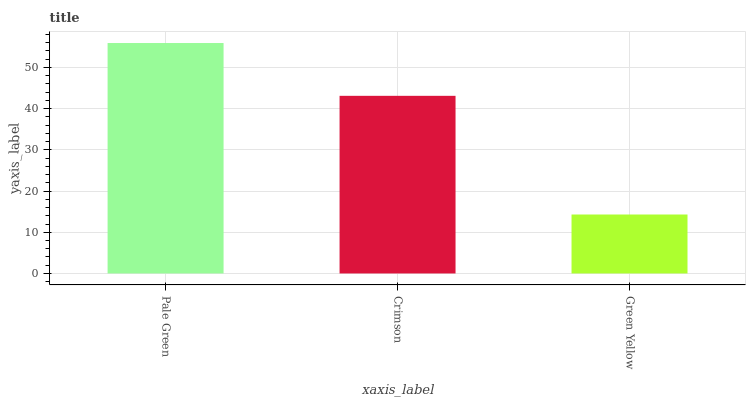Is Green Yellow the minimum?
Answer yes or no. Yes. Is Pale Green the maximum?
Answer yes or no. Yes. Is Crimson the minimum?
Answer yes or no. No. Is Crimson the maximum?
Answer yes or no. No. Is Pale Green greater than Crimson?
Answer yes or no. Yes. Is Crimson less than Pale Green?
Answer yes or no. Yes. Is Crimson greater than Pale Green?
Answer yes or no. No. Is Pale Green less than Crimson?
Answer yes or no. No. Is Crimson the high median?
Answer yes or no. Yes. Is Crimson the low median?
Answer yes or no. Yes. Is Green Yellow the high median?
Answer yes or no. No. Is Green Yellow the low median?
Answer yes or no. No. 